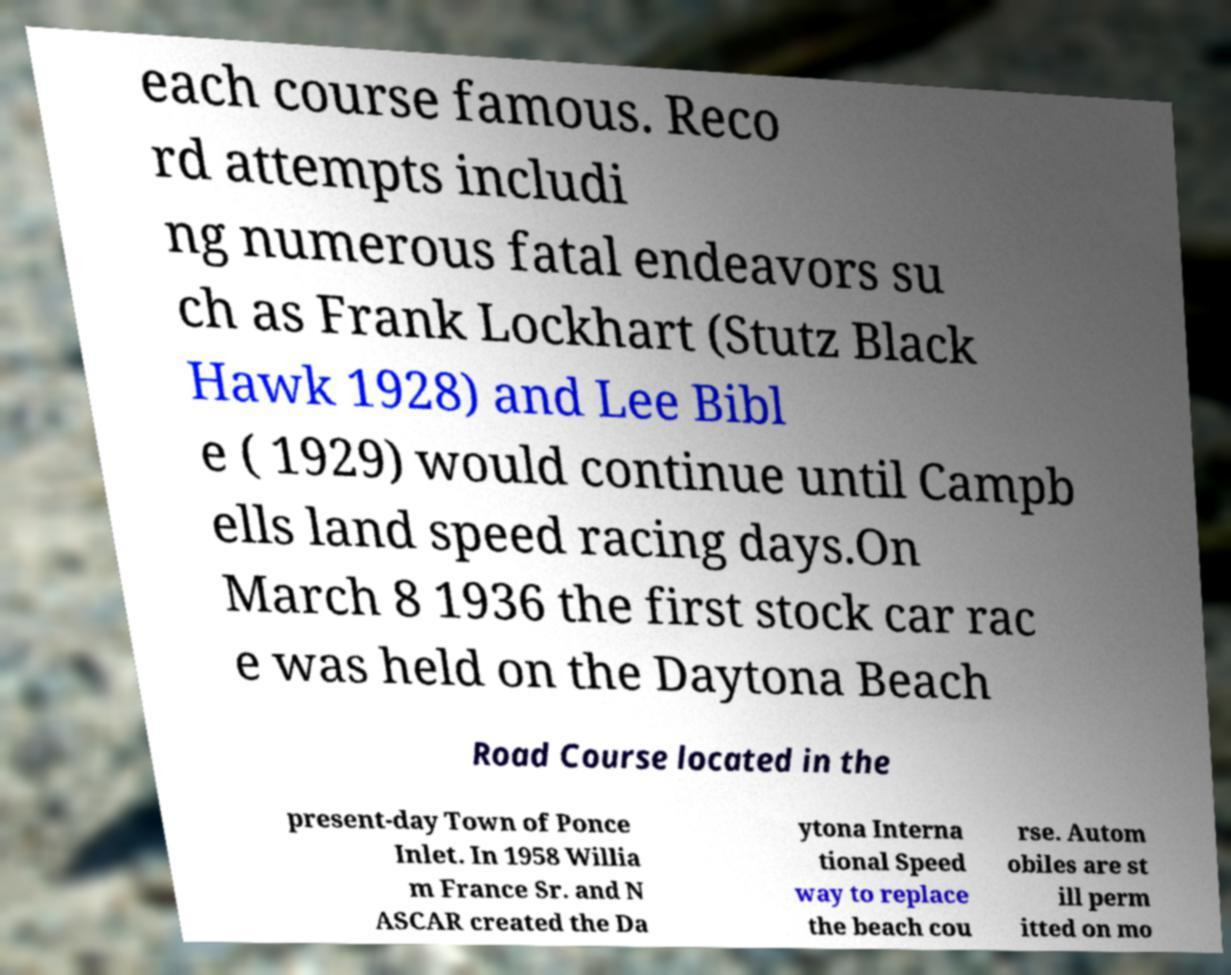For documentation purposes, I need the text within this image transcribed. Could you provide that? each course famous. Reco rd attempts includi ng numerous fatal endeavors su ch as Frank Lockhart (Stutz Black Hawk 1928) and Lee Bibl e ( 1929) would continue until Campb ells land speed racing days.On March 8 1936 the first stock car rac e was held on the Daytona Beach Road Course located in the present-day Town of Ponce Inlet. In 1958 Willia m France Sr. and N ASCAR created the Da ytona Interna tional Speed way to replace the beach cou rse. Autom obiles are st ill perm itted on mo 